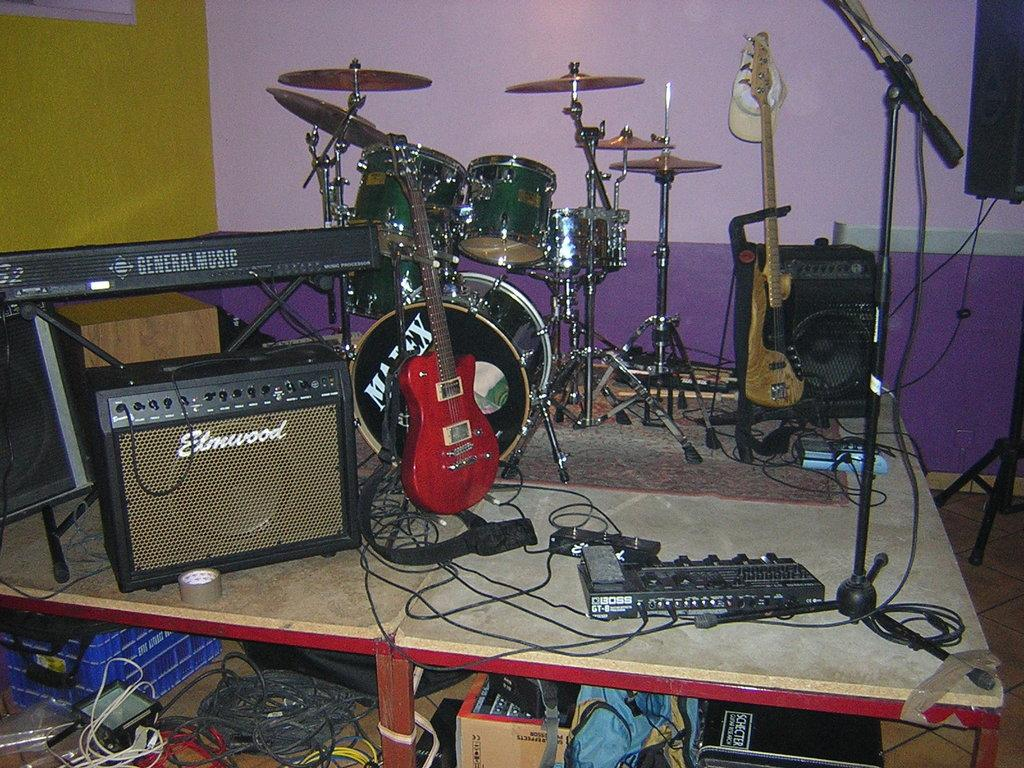What type of objects are present in the image? There are many musical instruments in the image. Can you describe any specific features of the image? Yes, there is a wire and a sound box in the image. Where is the box located in the image? The box is on the table in the image. What can be seen in the background of the image? There is a wall in the background of the image. What type of payment is required to enter the room in the image? There is no indication of a room or any payment required in the image; it primarily features musical instruments and related objects. 